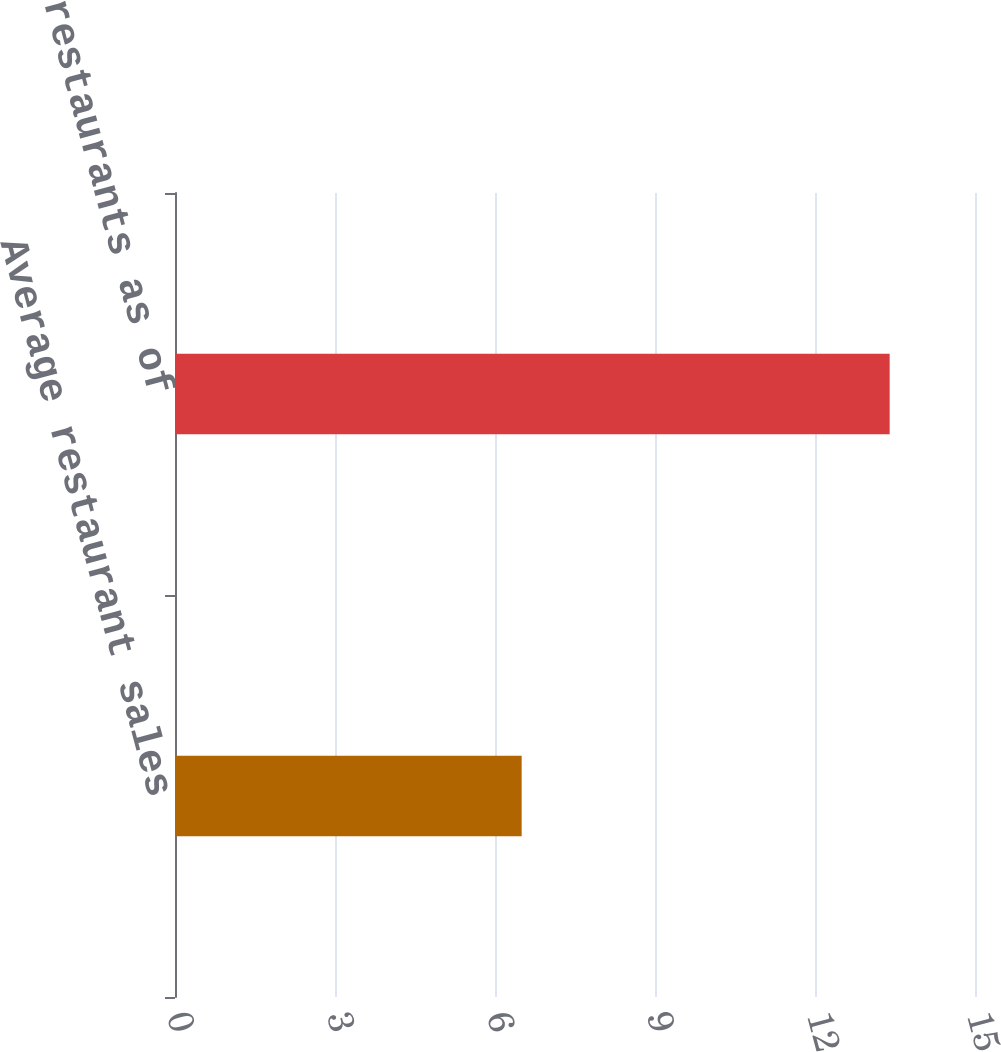<chart> <loc_0><loc_0><loc_500><loc_500><bar_chart><fcel>Average restaurant sales<fcel>Number of restaurants as of<nl><fcel>6.5<fcel>13.4<nl></chart> 